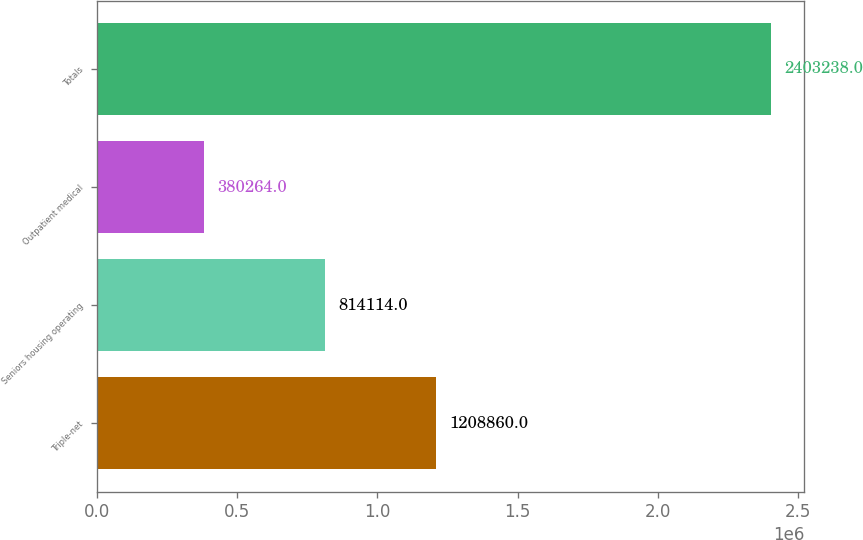Convert chart to OTSL. <chart><loc_0><loc_0><loc_500><loc_500><bar_chart><fcel>Triple-net<fcel>Seniors housing operating<fcel>Outpatient medical<fcel>Totals<nl><fcel>1.20886e+06<fcel>814114<fcel>380264<fcel>2.40324e+06<nl></chart> 